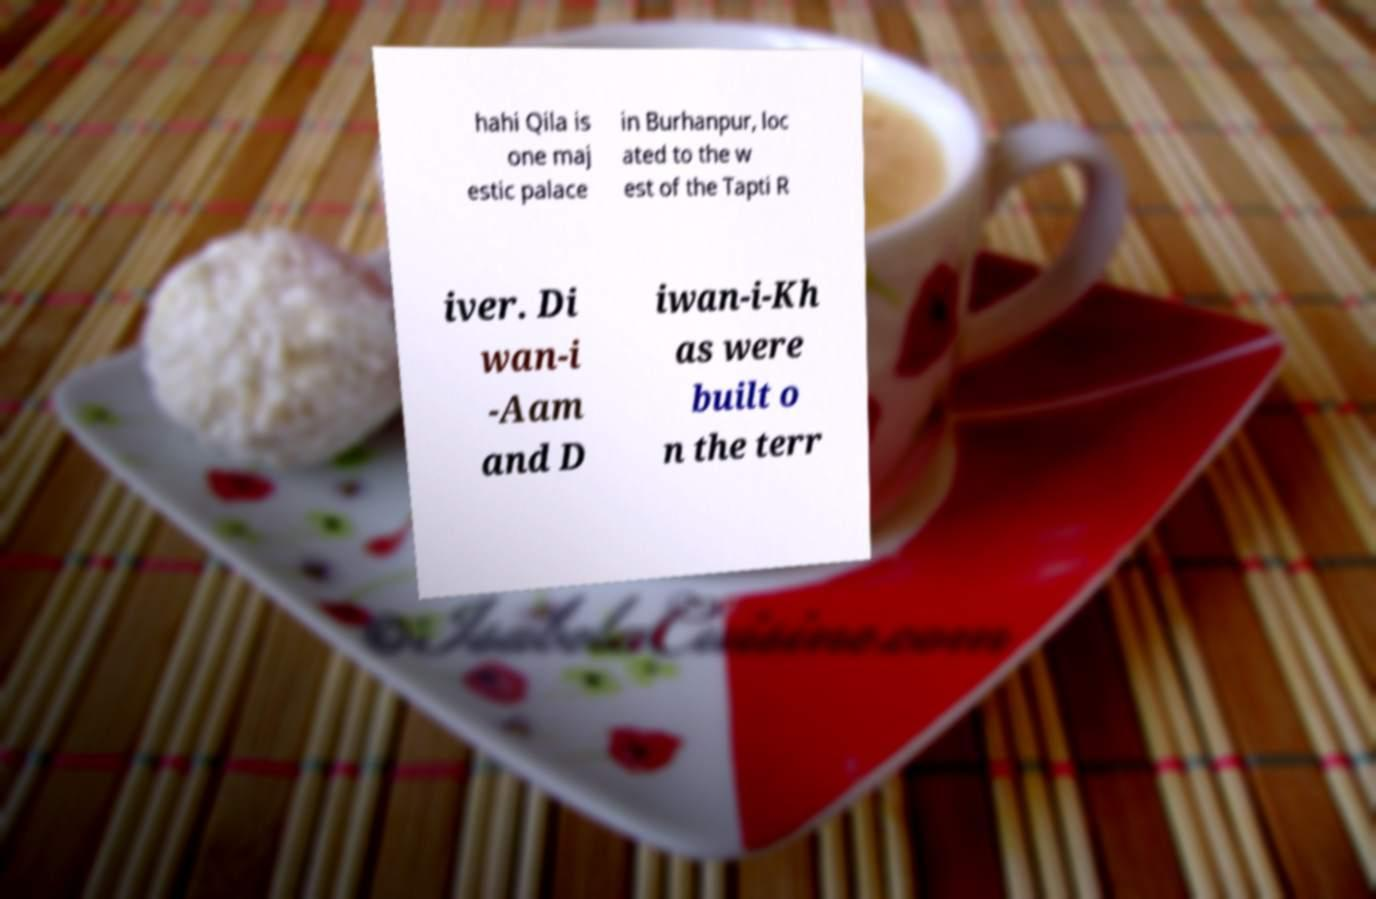Please identify and transcribe the text found in this image. hahi Qila is one maj estic palace in Burhanpur, loc ated to the w est of the Tapti R iver. Di wan-i -Aam and D iwan-i-Kh as were built o n the terr 